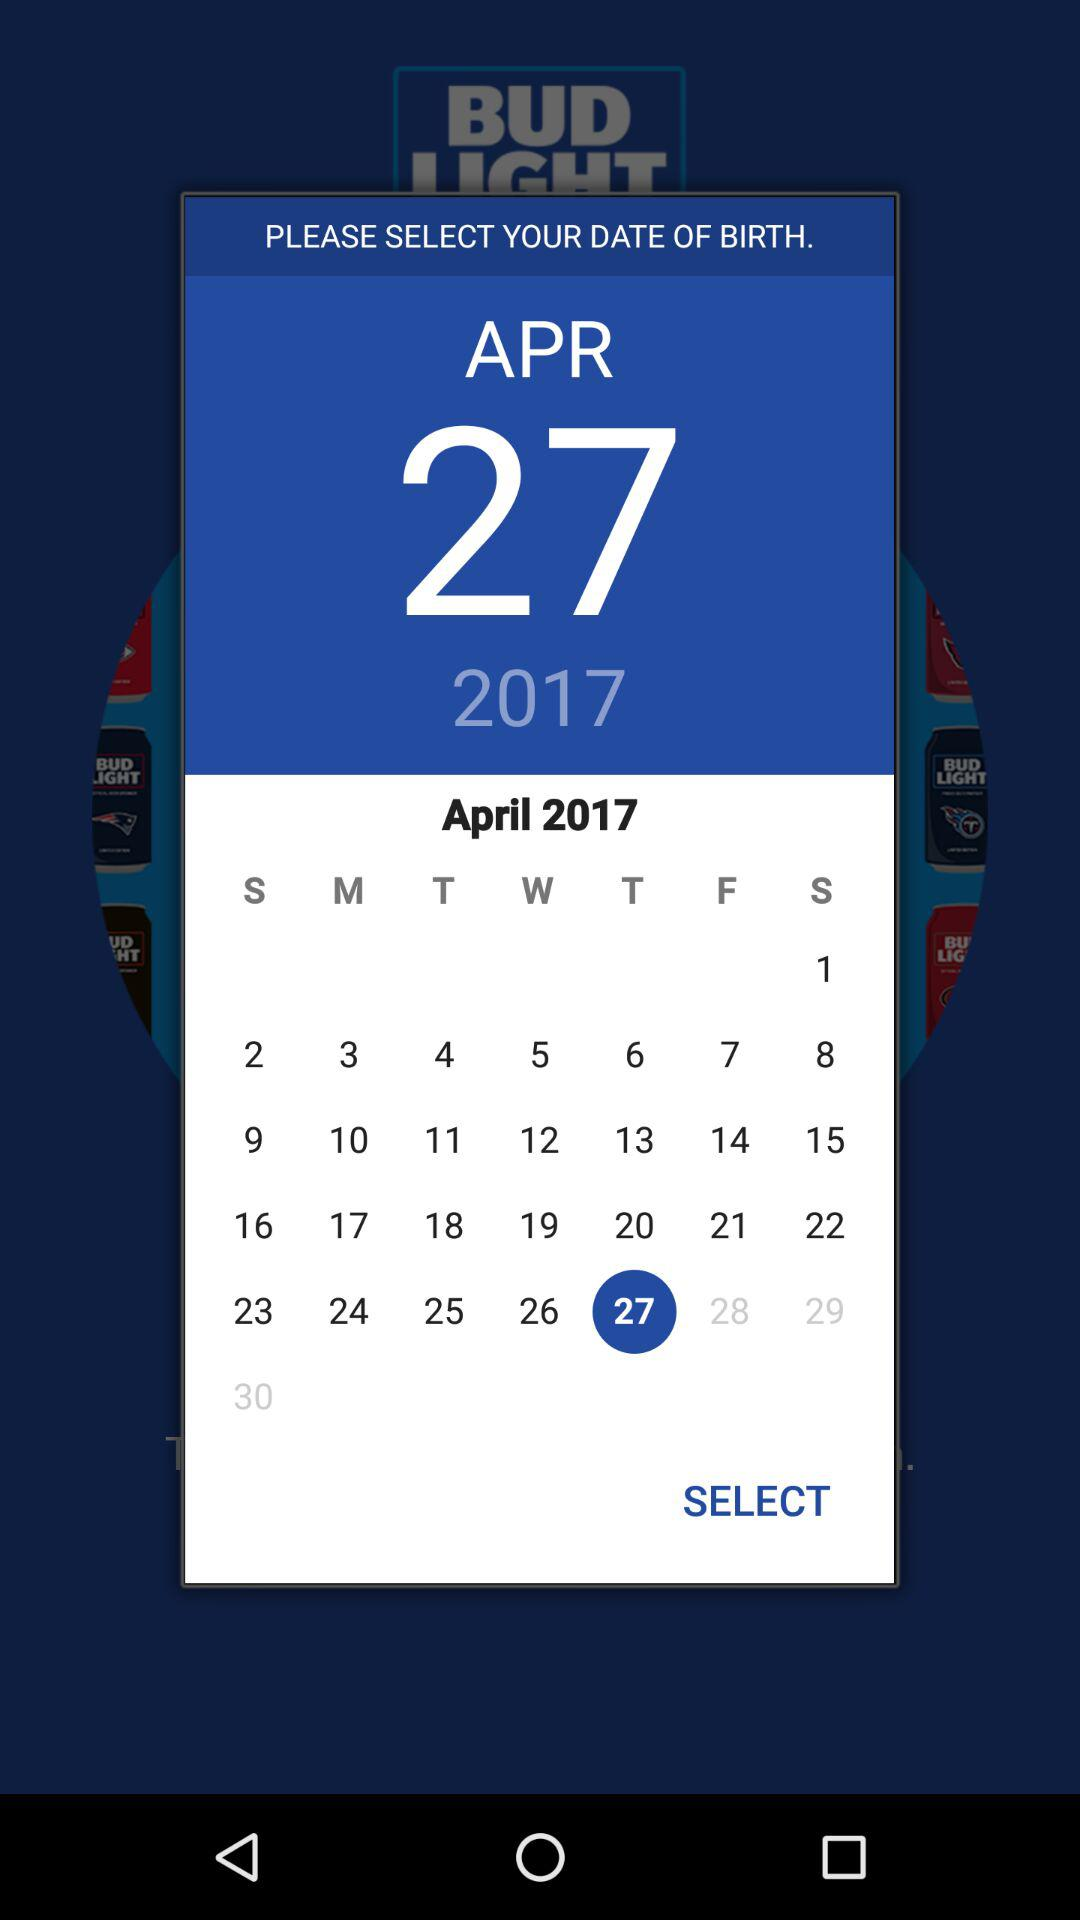What is the selected date? The selected date is Thursday, April 27, 2017. 